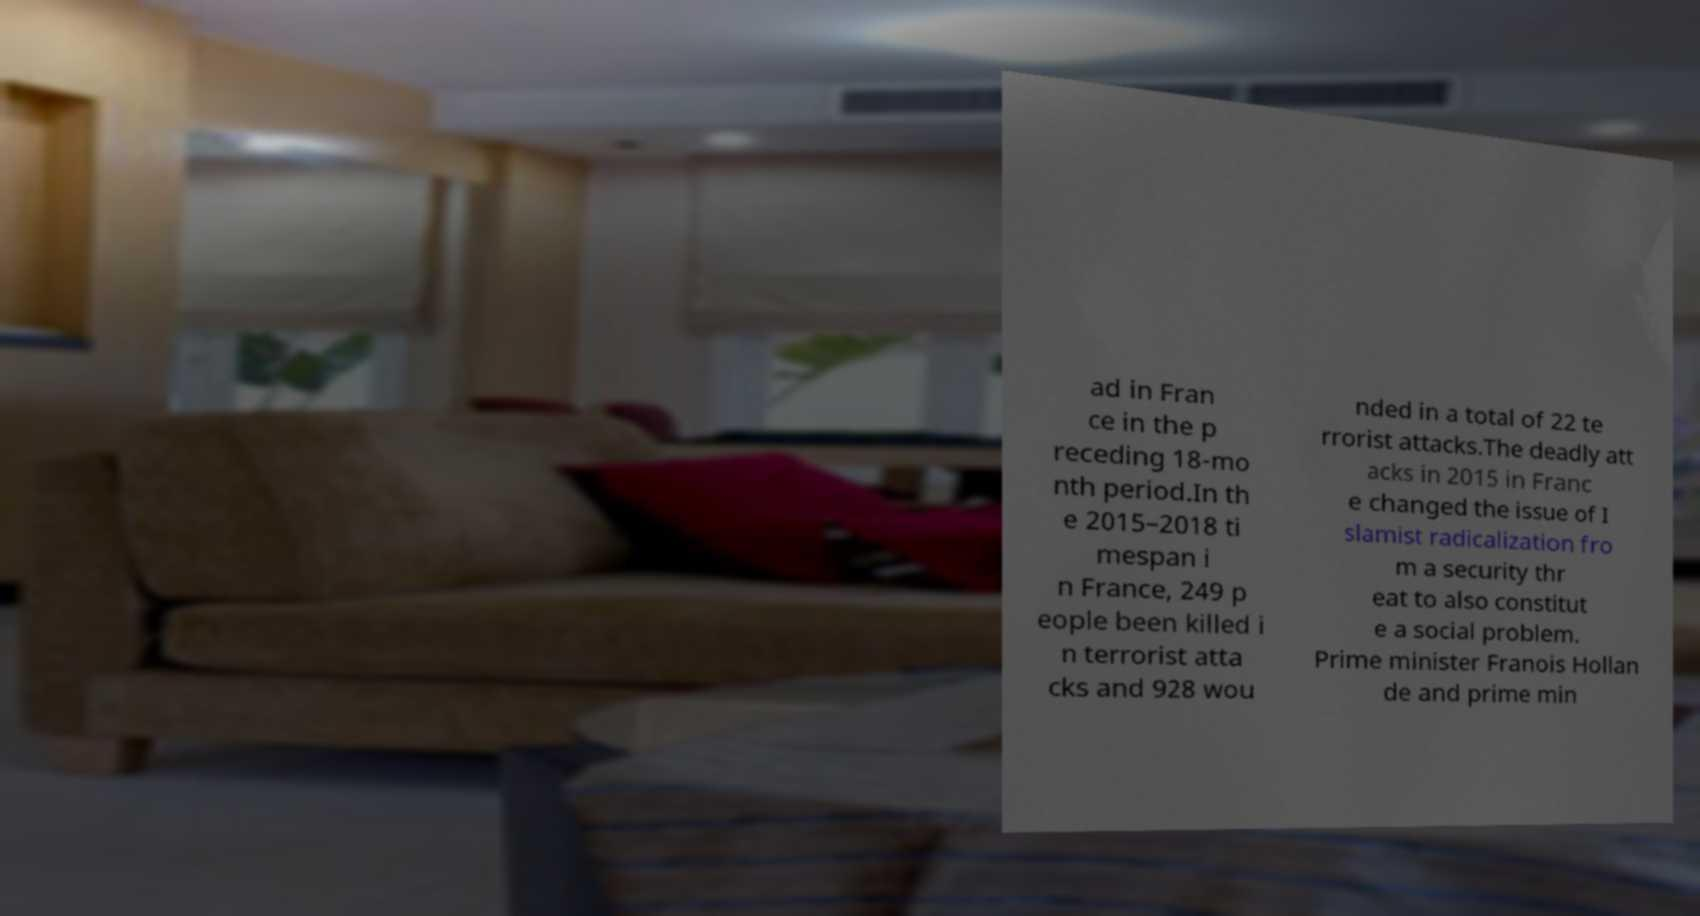Can you accurately transcribe the text from the provided image for me? ad in Fran ce in the p receding 18-mo nth period.In th e 2015–2018 ti mespan i n France, 249 p eople been killed i n terrorist atta cks and 928 wou nded in a total of 22 te rrorist attacks.The deadly att acks in 2015 in Franc e changed the issue of I slamist radicalization fro m a security thr eat to also constitut e a social problem. Prime minister Franois Hollan de and prime min 